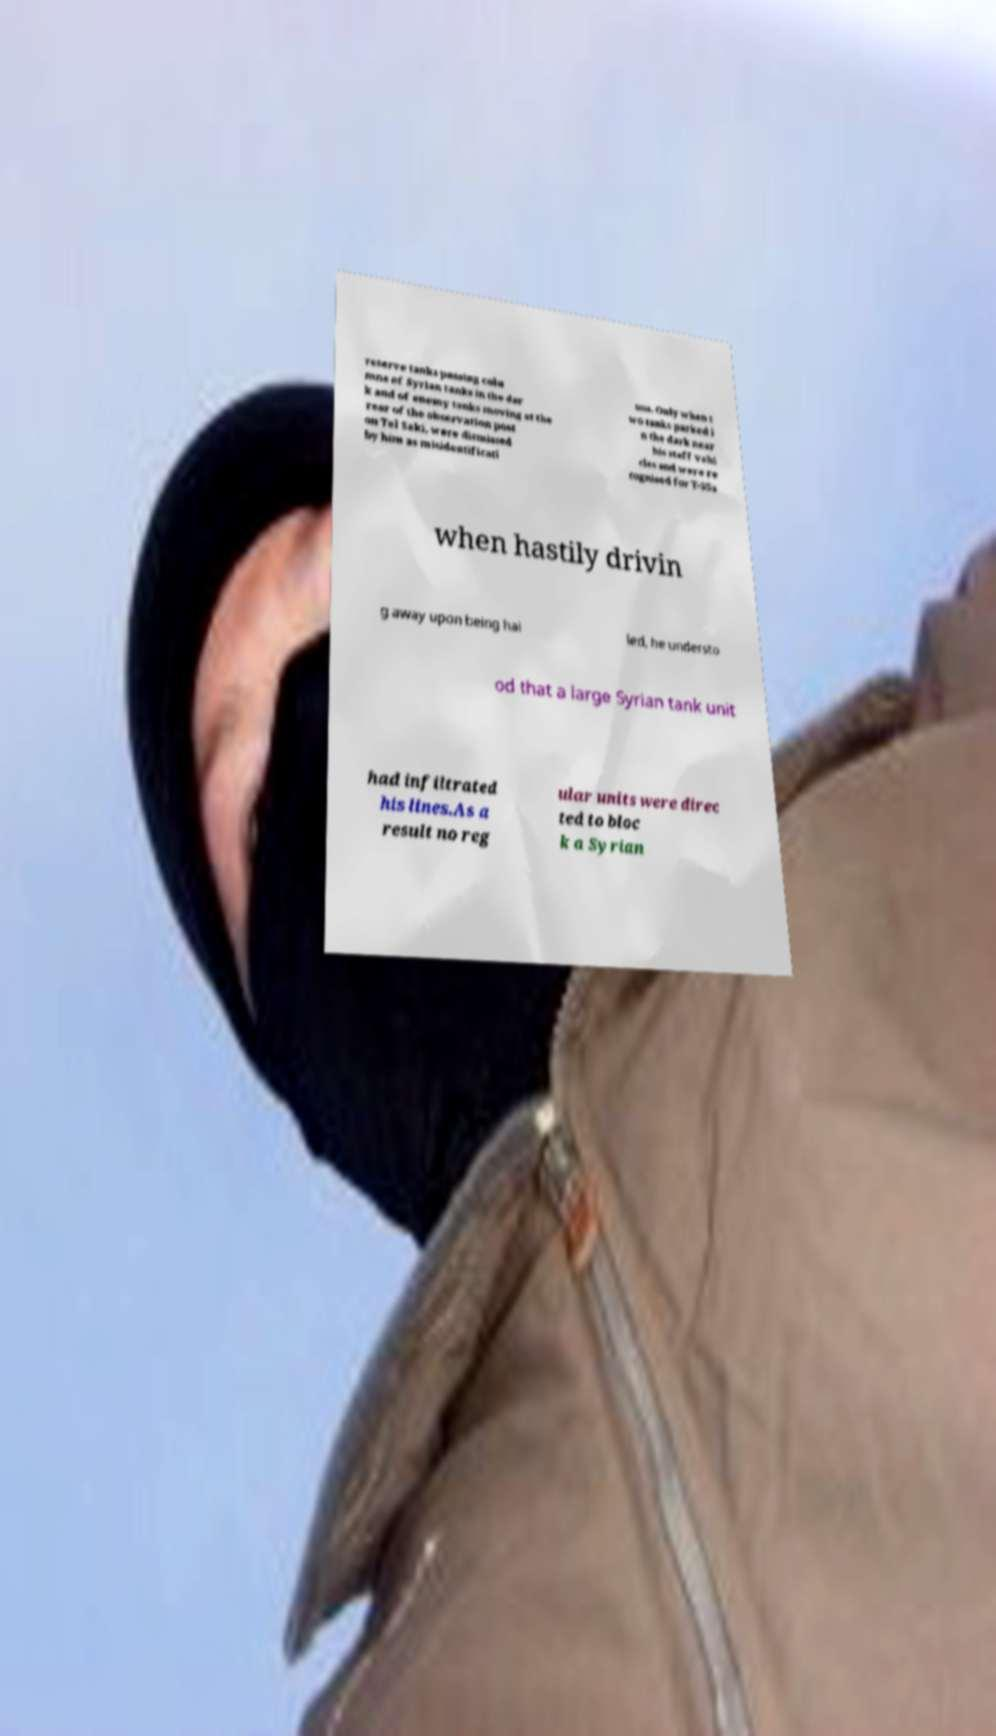There's text embedded in this image that I need extracted. Can you transcribe it verbatim? reserve tanks passing colu mns of Syrian tanks in the dar k and of enemy tanks moving at the rear of the observation post on Tel Saki, were dismissed by him as misidentificati ons. Only when t wo tanks parked i n the dark near his staff vehi cles and were re cognised for T-55s when hastily drivin g away upon being hai led, he understo od that a large Syrian tank unit had infiltrated his lines.As a result no reg ular units were direc ted to bloc k a Syrian 